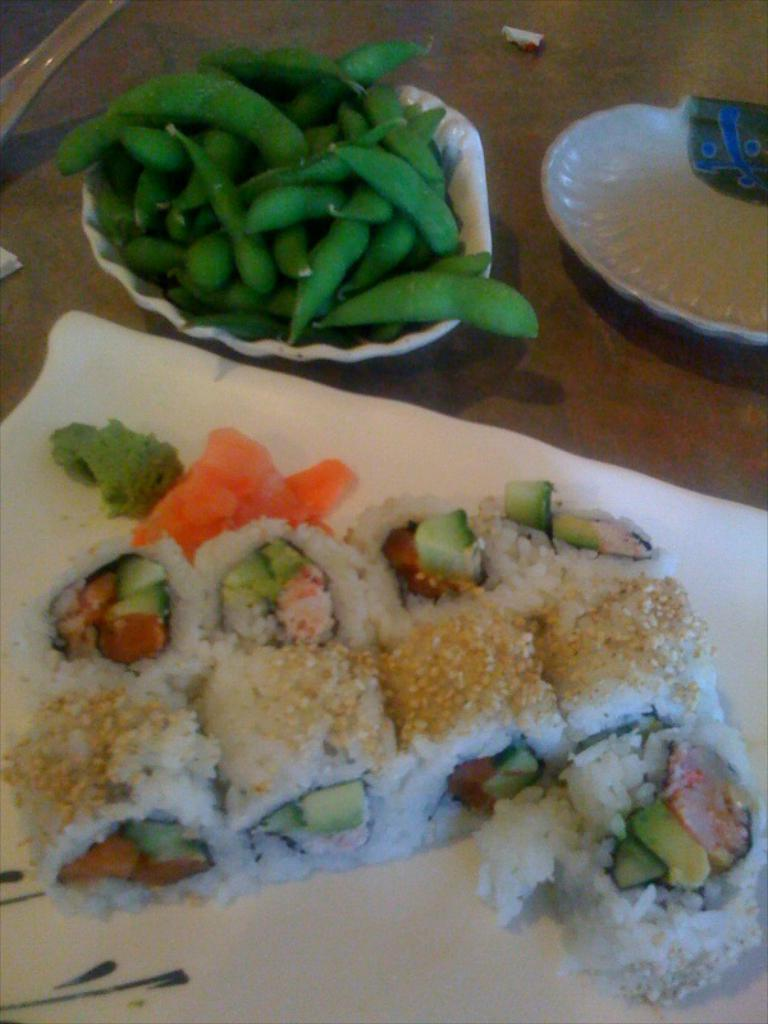What is present in the tray in the image? There is food in the tray. What other dish can be seen in the image? There is a plate on the side. What type of food is in the bowl? There are peas in the bowl. What type of canvas is used to create the building in the image? There is no building present in the image; it features a tray with food, a plate, and a bowl of peas. How does the taste of the peas compare to the taste of the food on the plate? The image does not provide information about the taste of the food, as it is a visual representation only. 